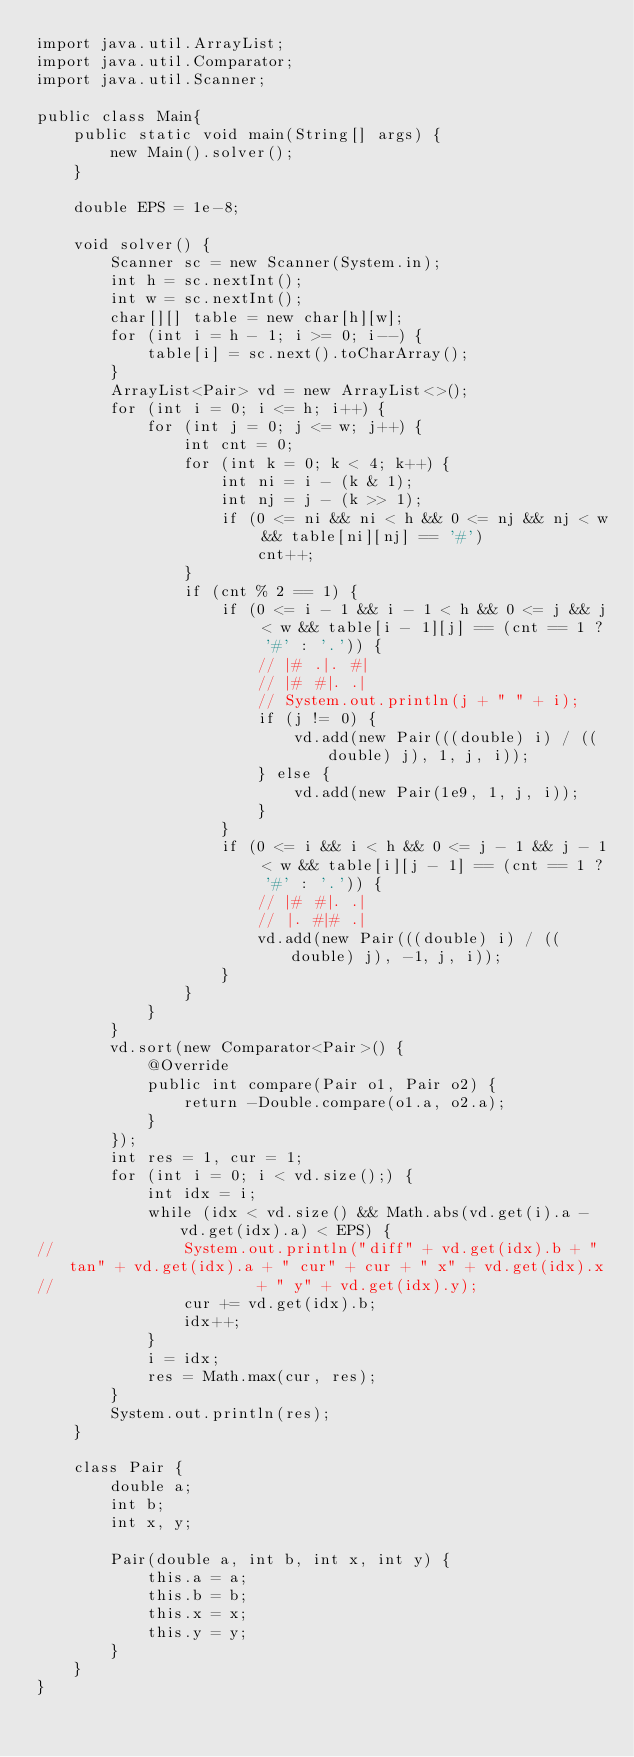<code> <loc_0><loc_0><loc_500><loc_500><_Java_>import java.util.ArrayList;
import java.util.Comparator;
import java.util.Scanner;

public class Main{
	public static void main(String[] args) {
		new Main().solver();
	}

	double EPS = 1e-8;

	void solver() {
		Scanner sc = new Scanner(System.in);
		int h = sc.nextInt();
		int w = sc.nextInt();
		char[][] table = new char[h][w];
		for (int i = h - 1; i >= 0; i--) {
			table[i] = sc.next().toCharArray();
		}
		ArrayList<Pair> vd = new ArrayList<>();
		for (int i = 0; i <= h; i++) {
			for (int j = 0; j <= w; j++) {
				int cnt = 0;
				for (int k = 0; k < 4; k++) {
					int ni = i - (k & 1);
					int nj = j - (k >> 1);
					if (0 <= ni && ni < h && 0 <= nj && nj < w && table[ni][nj] == '#')
						cnt++;
				}
				if (cnt % 2 == 1) {
					if (0 <= i - 1 && i - 1 < h && 0 <= j && j < w && table[i - 1][j] == (cnt == 1 ? '#' : '.')) {
						// |# .|. #|
						// |# #|. .|
						// System.out.println(j + " " + i);
						if (j != 0) {
							vd.add(new Pair(((double) i) / ((double) j), 1, j, i));
						} else {
							vd.add(new Pair(1e9, 1, j, i));
						}
					}
					if (0 <= i && i < h && 0 <= j - 1 && j - 1 < w && table[i][j - 1] == (cnt == 1 ? '#' : '.')) {
						// |# #|. .|
						// |. #|# .|
						vd.add(new Pair(((double) i) / ((double) j), -1, j, i));
					}
				}
			}
		}
		vd.sort(new Comparator<Pair>() {
			@Override
			public int compare(Pair o1, Pair o2) {
				return -Double.compare(o1.a, o2.a);
			}
		});
		int res = 1, cur = 1;
		for (int i = 0; i < vd.size();) {
			int idx = i;
			while (idx < vd.size() && Math.abs(vd.get(i).a - vd.get(idx).a) < EPS) {
//				System.out.println("diff" + vd.get(idx).b + " tan" + vd.get(idx).a + " cur" + cur + " x" + vd.get(idx).x
//						+ " y" + vd.get(idx).y);
				cur += vd.get(idx).b;
				idx++;
			}
			i = idx;
			res = Math.max(cur, res);
		}
		System.out.println(res);
	}

	class Pair {
		double a;
		int b;
		int x, y;

		Pair(double a, int b, int x, int y) {
			this.a = a;
			this.b = b;
			this.x = x;
			this.y = y;
		}
	}
}</code> 